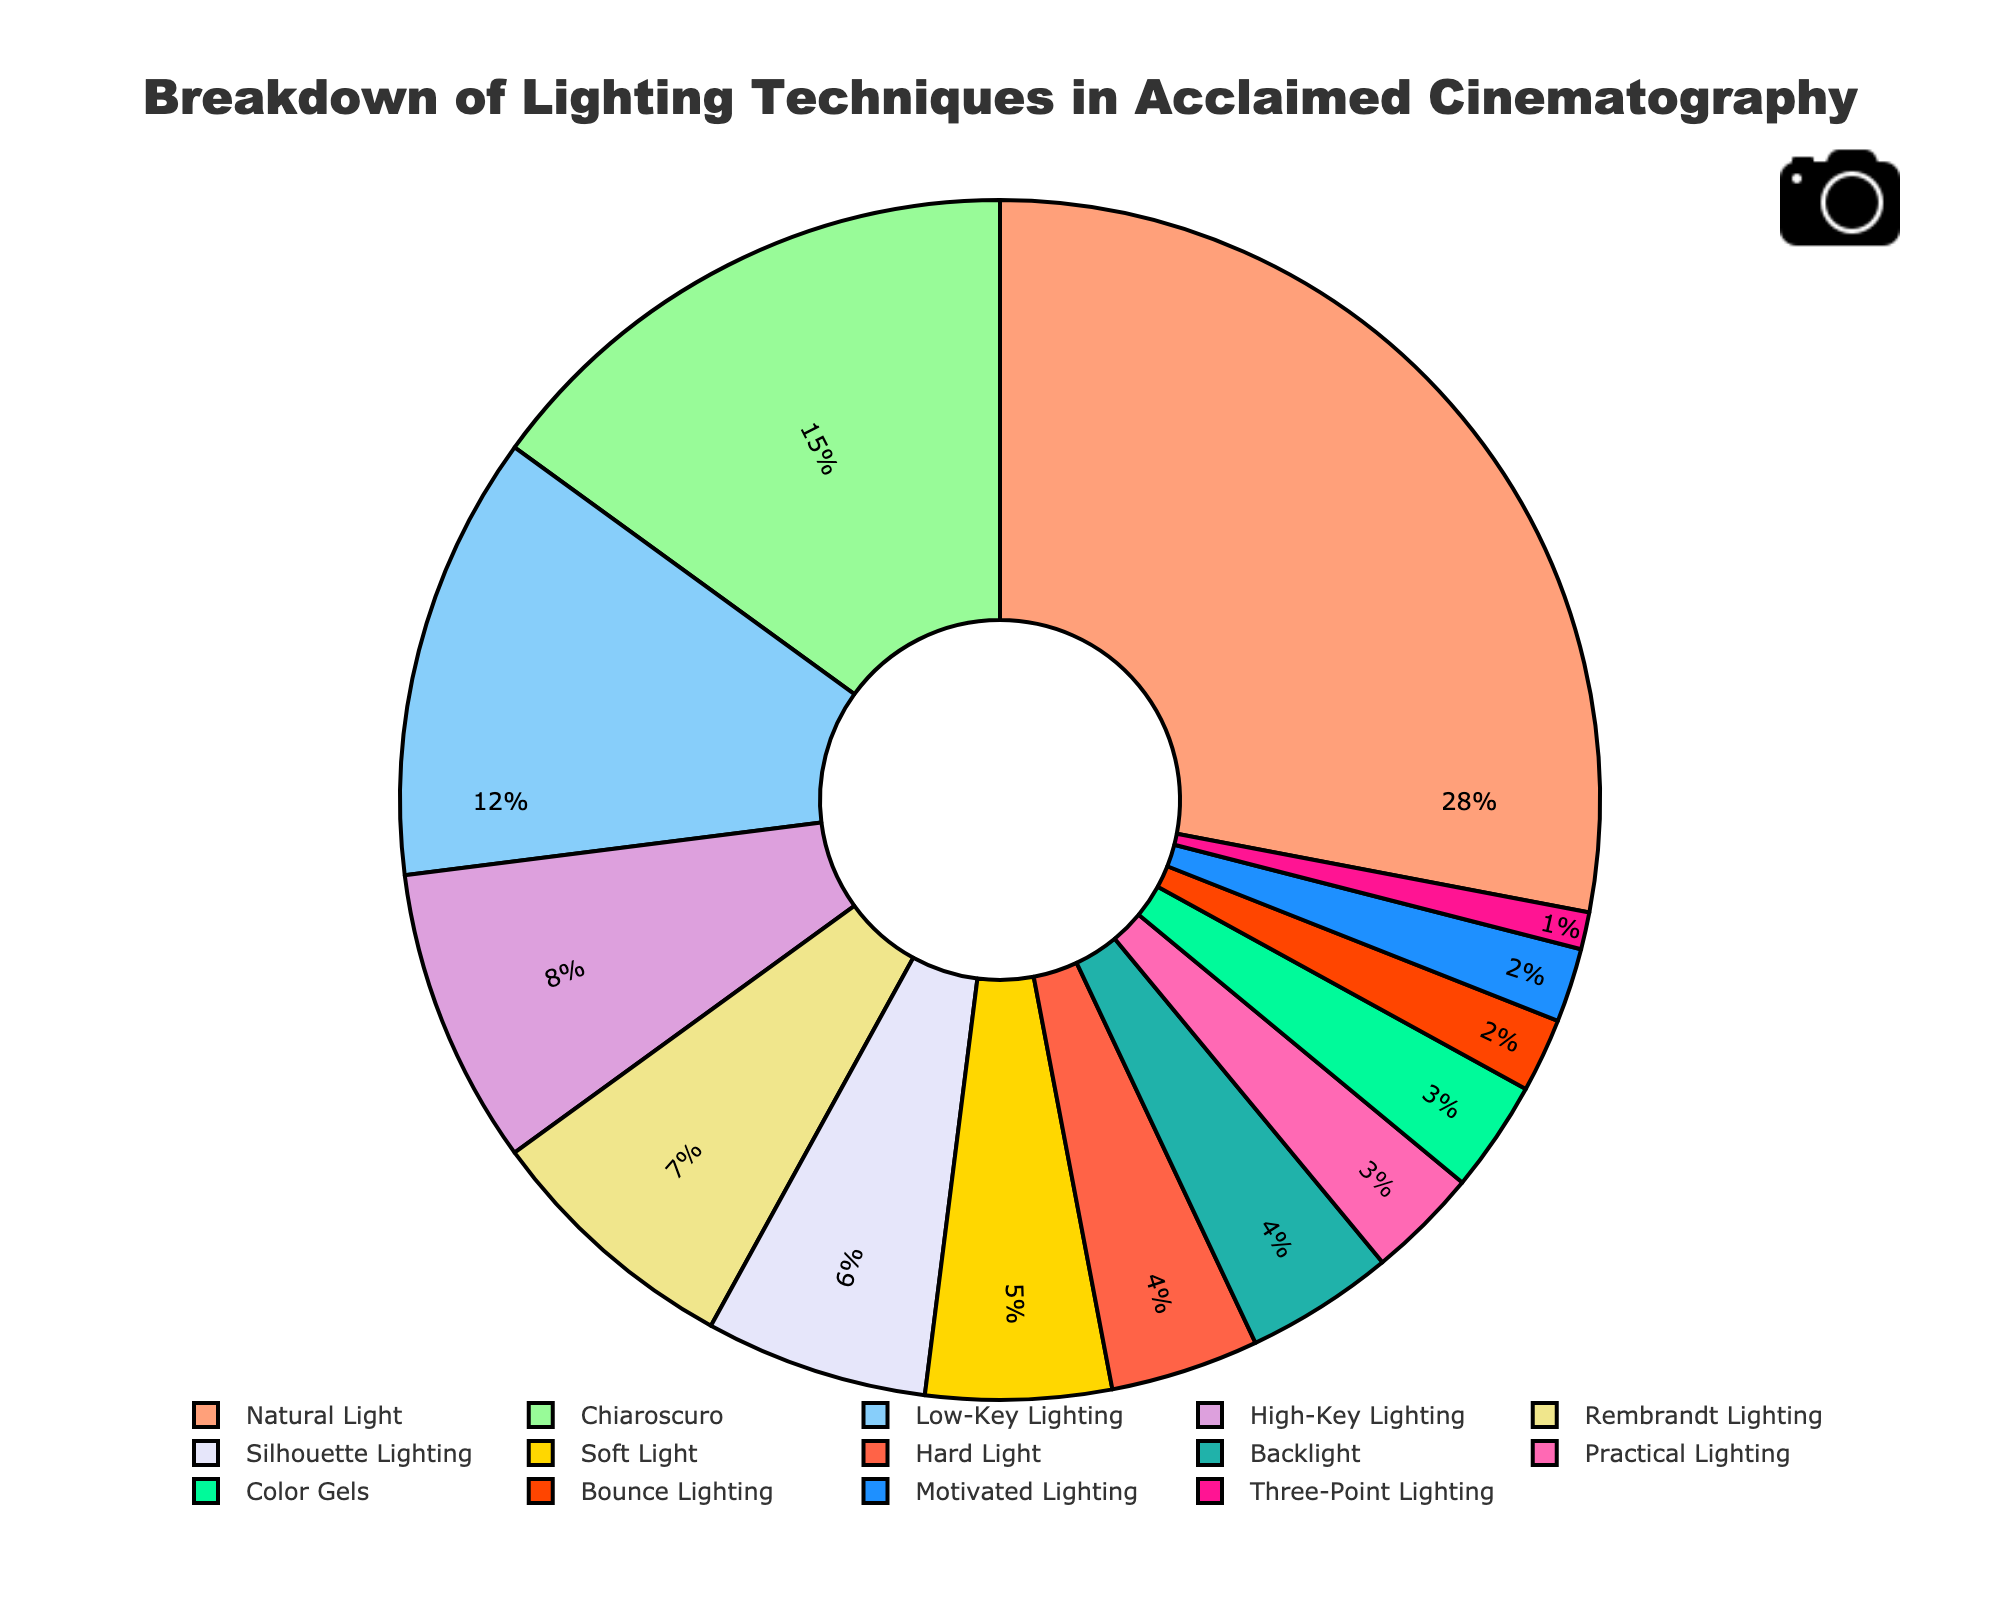Which lighting technique is used the most in critically acclaimed cinematography? By looking at the figure, we see that "Natural Light" has the largest section of the pie chart, indicating it is used the most at 28%.
Answer: Natural Light What percentage of the lighting techniques employ Chiaroscuro and Rembrandt Lighting combined? Chiaroscuro and Rembrandt Lighting have percentages of 15% and 7%, respectively. Adding these together gives 15% + 7% = 22%.
Answer: 22% Which lighting technique is represented by the green segment of the pie chart? The green segment is visually identified as representing "Practical Lighting," which accounts for 3% of the total.
Answer: Practical Lighting Is Low-Key Lighting used more or less than High-Key Lighting, and by how much? Low-Key Lighting accounts for 12%, whereas High-Key Lighting accounts for 8%. The difference is 12% - 8% = 4%.
Answer: More by 4% How many techniques are used less frequently than Chiaroscuro? Chiaroscuro is the second largest segment with 15%. Lighting techniques with less frequency include Low-Key Lighting, High-Key Lighting, Rembrandt Lighting, Silhouette Lighting, Soft Light, Hard Light, Backlight, Practical Lighting, Color Gels, Bounce Lighting, Motivated Lighting, and Three-Point Lighting. This sums up to 11 techniques.
Answer: 11 Is the combined usage of Low-Key Lighting and Soft Light greater than Natural Light? Low-Key Lighting accounts for 12% and Soft Light for 5%. Combined, that is 12% + 5% = 17%, whereas Natural Light is 28%. Hence, 17% is less than 28%.
Answer: No What is the total percentage of techniques used less than 5% each? The techniques used less than 5% each are Hard Light (4%), Backlight (4%), Practical Lighting (3%), Color Gels (3%), Bounce Lighting (2%), Motivated Lighting (2%), and Three-Point Lighting (1%). Adding these gives 4% + 4% + 3% + 3% + 2% + 2% + 1% = 19%.
Answer: 19% Among the visualized techniques, which one is depicted using the yellow segment and what is its percentage? The yellow segment represents "High-Key Lighting," which accounts for 8% of the total.
Answer: High-Key Lighting, 8% How does the percentage of Chiaroscuro compare to the combined percentage of Silhouette Lighting and Bounce Lighting? Chiaroscuro accounts for 15%. Silhouette lighting is 6% and Bounce Lighting is 2%. The combined percentage is 6% + 2% = 8%. So, 15% is greater than 8%.
Answer: Chiaroscuro is greater by 7% Which lighting technique is represented by the purple segment and what is its percentage? The purple segment represents "Silhouette Lighting," with a percentage of 6%.
Answer: Silhouette Lighting, 6% 